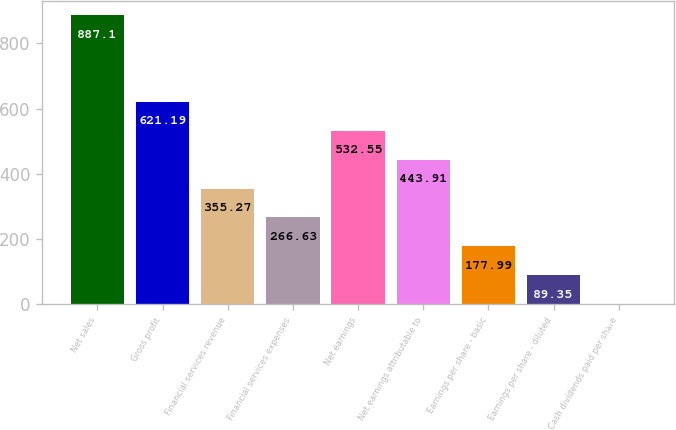Convert chart. <chart><loc_0><loc_0><loc_500><loc_500><bar_chart><fcel>Net sales<fcel>Gross profit<fcel>Financial services revenue<fcel>Financial services expenses<fcel>Net earnings<fcel>Net earnings attributable to<fcel>Earnings per share - basic<fcel>Earnings per share - diluted<fcel>Cash dividends paid per share<nl><fcel>887.1<fcel>621.19<fcel>355.27<fcel>266.63<fcel>532.55<fcel>443.91<fcel>177.99<fcel>89.35<fcel>0.71<nl></chart> 